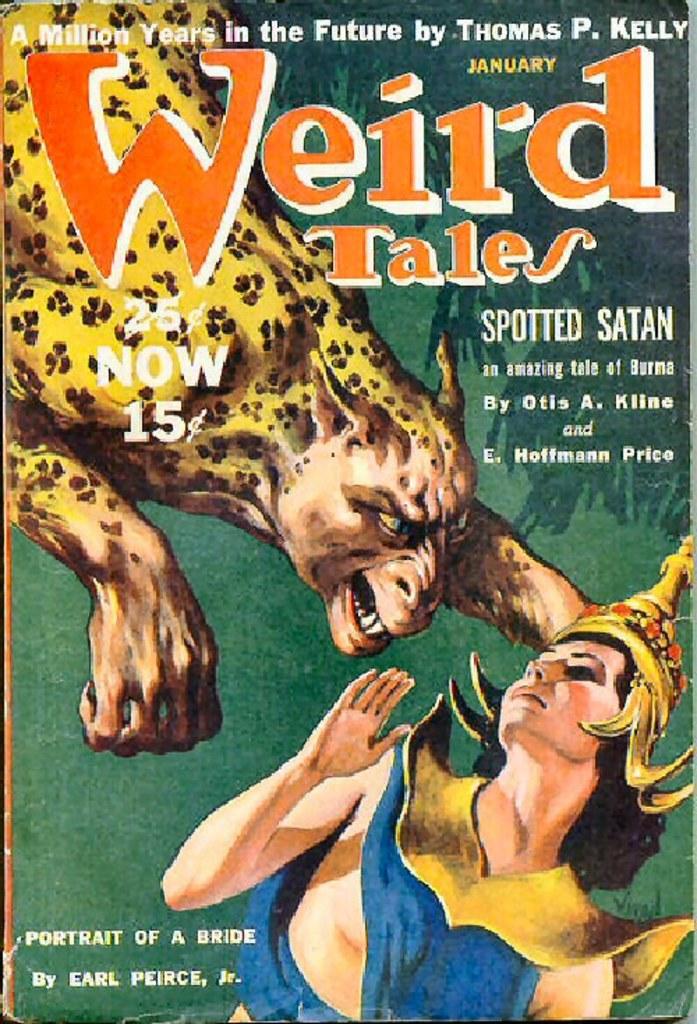Who wrote portrait of a bride?
Your answer should be compact. Earl peirce, jr. What month was this published?
Offer a very short reply. January. 